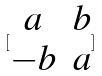Convert formula to latex. <formula><loc_0><loc_0><loc_500><loc_500>[ \begin{matrix} a & b \\ - b & a \end{matrix} ]</formula> 